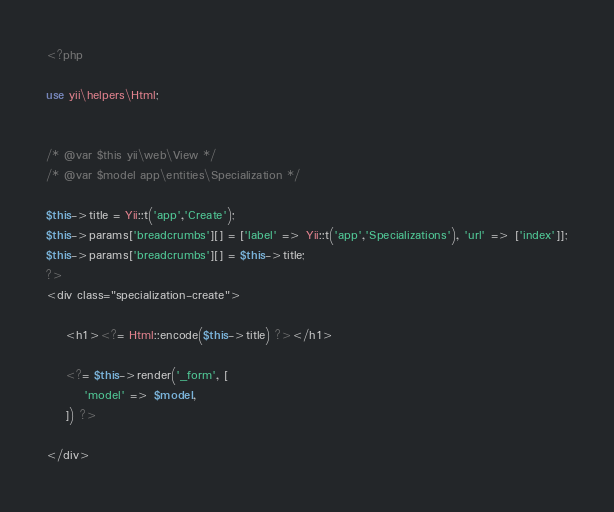Convert code to text. <code><loc_0><loc_0><loc_500><loc_500><_PHP_><?php

use yii\helpers\Html;


/* @var $this yii\web\View */
/* @var $model app\entities\Specialization */

$this->title = Yii::t('app','Create');
$this->params['breadcrumbs'][] = ['label' => Yii::t('app','Specializations'), 'url' => ['index']];
$this->params['breadcrumbs'][] = $this->title;
?>
<div class="specialization-create">

    <h1><?= Html::encode($this->title) ?></h1>

    <?= $this->render('_form', [
        'model' => $model,
    ]) ?>

</div>
</code> 